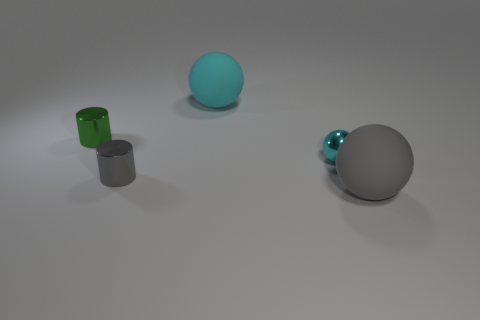Is the shape of the metal object that is to the left of the gray metal object the same as  the small gray metal object?
Your answer should be very brief. Yes. There is a gray metal object in front of the tiny metallic object that is right of the large ball that is behind the tiny green object; what is its shape?
Offer a very short reply. Cylinder. What is the object that is to the right of the tiny gray thing and to the left of the cyan metallic sphere made of?
Provide a succinct answer. Rubber. Is the number of matte balls less than the number of shiny things?
Your answer should be compact. Yes. Do the large cyan thing and the tiny cyan metal thing behind the big gray matte thing have the same shape?
Provide a short and direct response. Yes. There is a shiny thing behind the cyan shiny ball; does it have the same size as the big gray matte thing?
Offer a terse response. No. What is the shape of the gray shiny object that is the same size as the cyan metallic object?
Offer a very short reply. Cylinder. Do the big cyan thing and the gray metal thing have the same shape?
Make the answer very short. No. How many gray things are the same shape as the small green shiny thing?
Your answer should be very brief. 1. There is a small green metal cylinder; what number of large rubber objects are in front of it?
Keep it short and to the point. 1. 